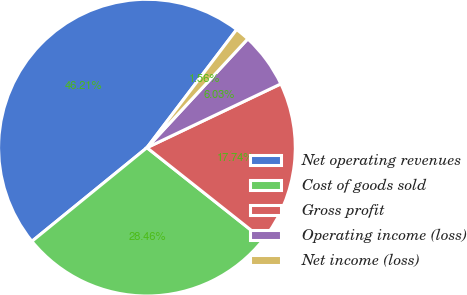<chart> <loc_0><loc_0><loc_500><loc_500><pie_chart><fcel>Net operating revenues<fcel>Cost of goods sold<fcel>Gross profit<fcel>Operating income (loss)<fcel>Net income (loss)<nl><fcel>46.21%<fcel>28.46%<fcel>17.74%<fcel>6.03%<fcel>1.56%<nl></chart> 